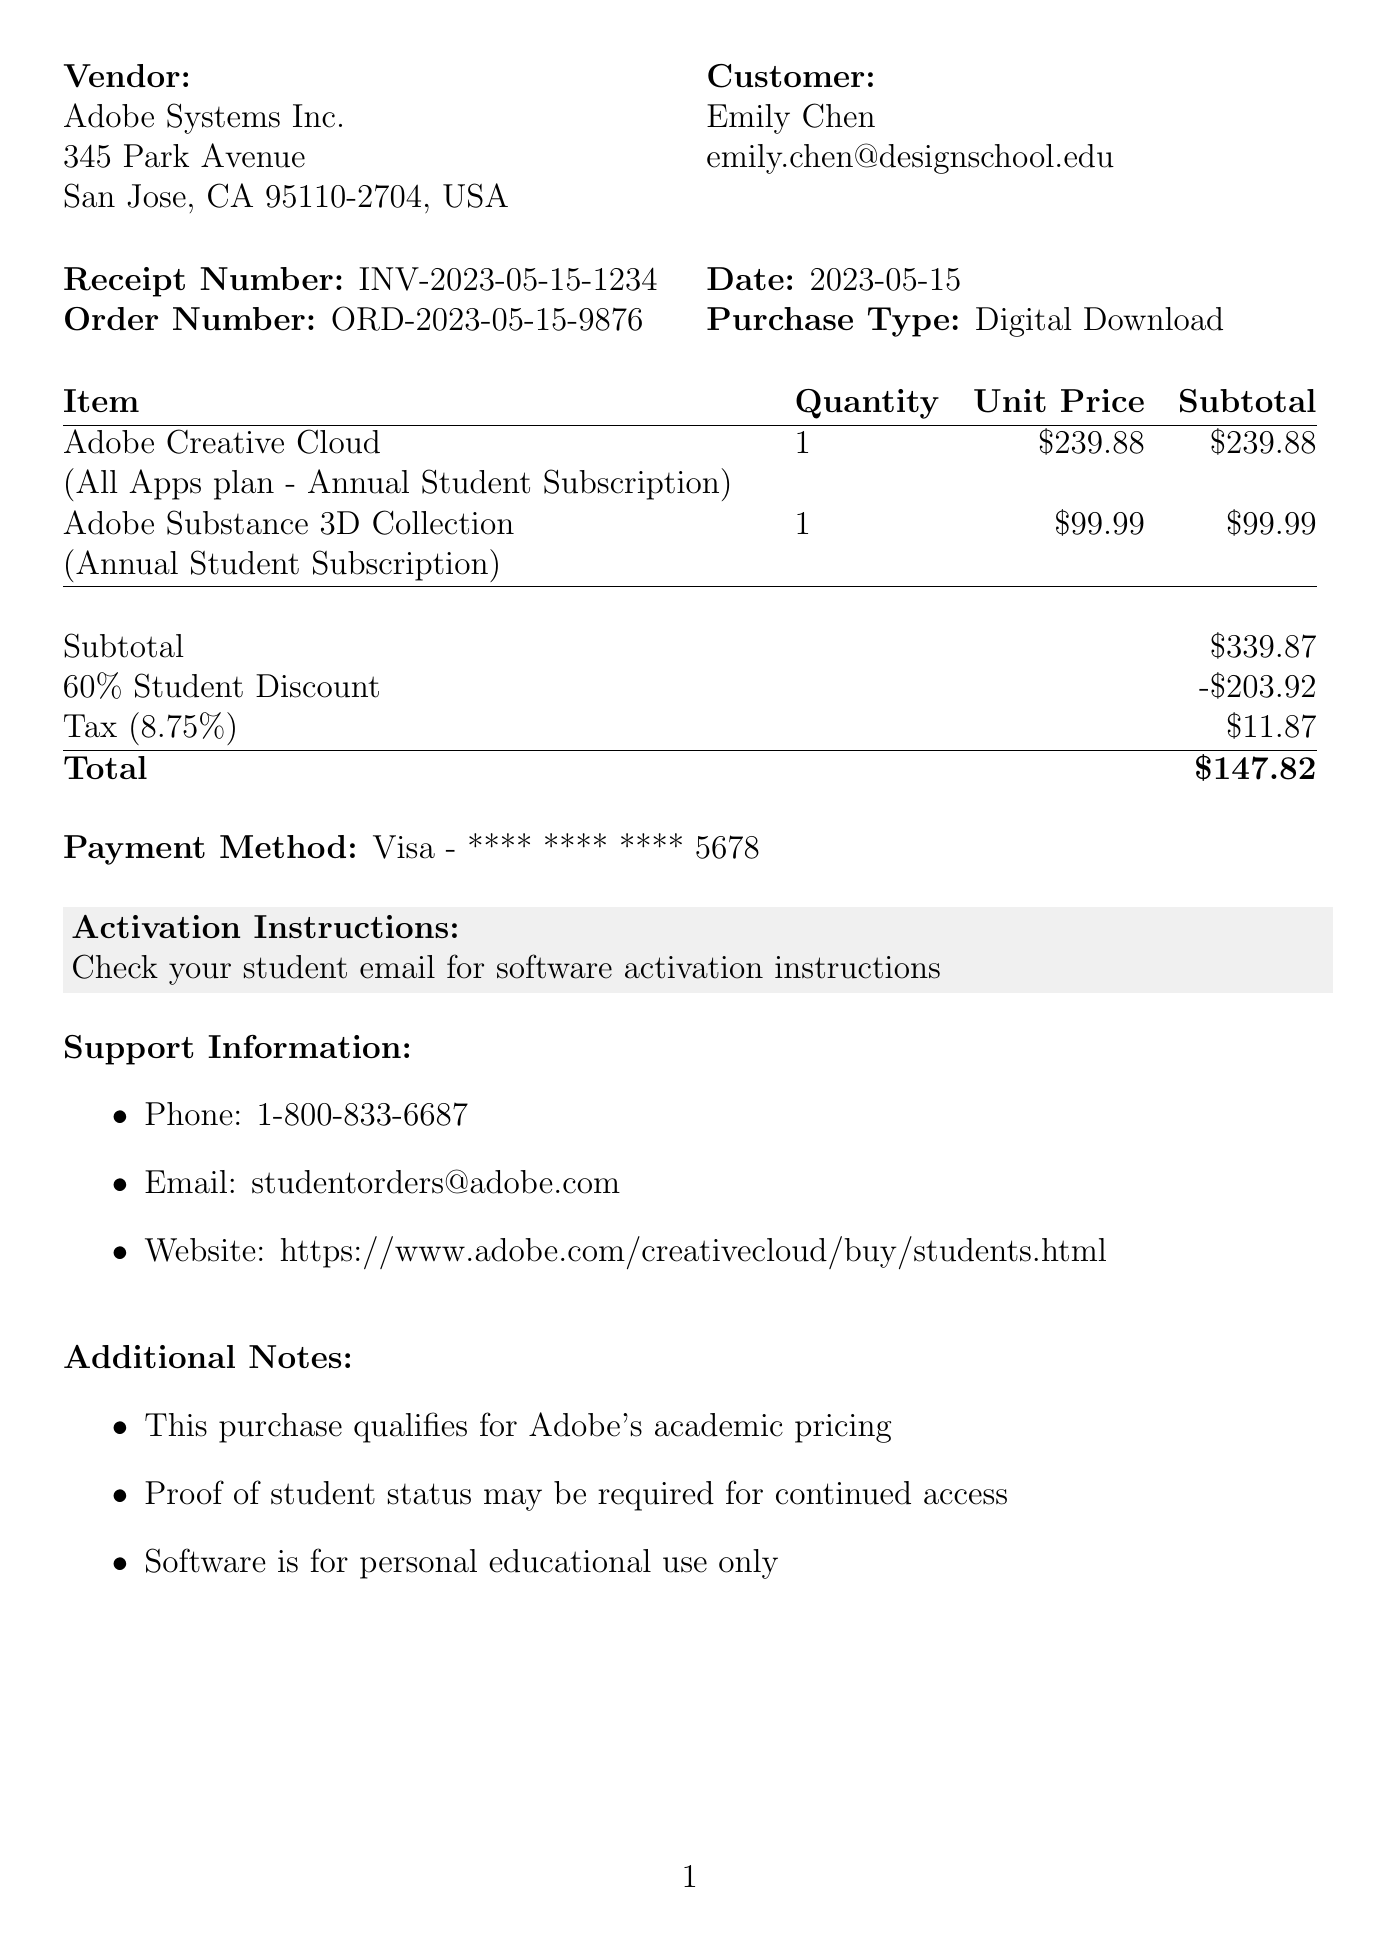What is the receipt number? The receipt number is listed at the top of the document under the receipt information section.
Answer: INV-2023-05-15-1234 Who is the customer? The customer’s name appears in the receipt under the customer information section.
Answer: Emily Chen What is the vendor's address? The vendor's address is specified right below the vendor's name on the receipt.
Answer: 345 Park Avenue, San Jose, CA 95110-2704, USA What is the total amount after applying the student discount? The total amount is calculated in the summary section of the purchase receipt, reflecting all discounts and taxes.
Answer: $147.82 What discount was applied to this purchase? The discount applied is noted in the summary section, detailing the percentage and the amount.
Answer: 60% Student Discount How much tax was charged on the purchase? The tax amount is displayed in the summary part of the document as part of the total calculation.
Answer: $11.87 What is the activation instruction? The activation instructions are provided in a highlighted box towards the end of the receipt.
Answer: Check your student email for software activation instructions What is the support phone number? The support phone number is listed in the support information section of the document.
Answer: 1-800-833-6687 What is the payment method used? The payment method can be found in the payment section of the receipt.
Answer: Visa - **** **** **** 5678 